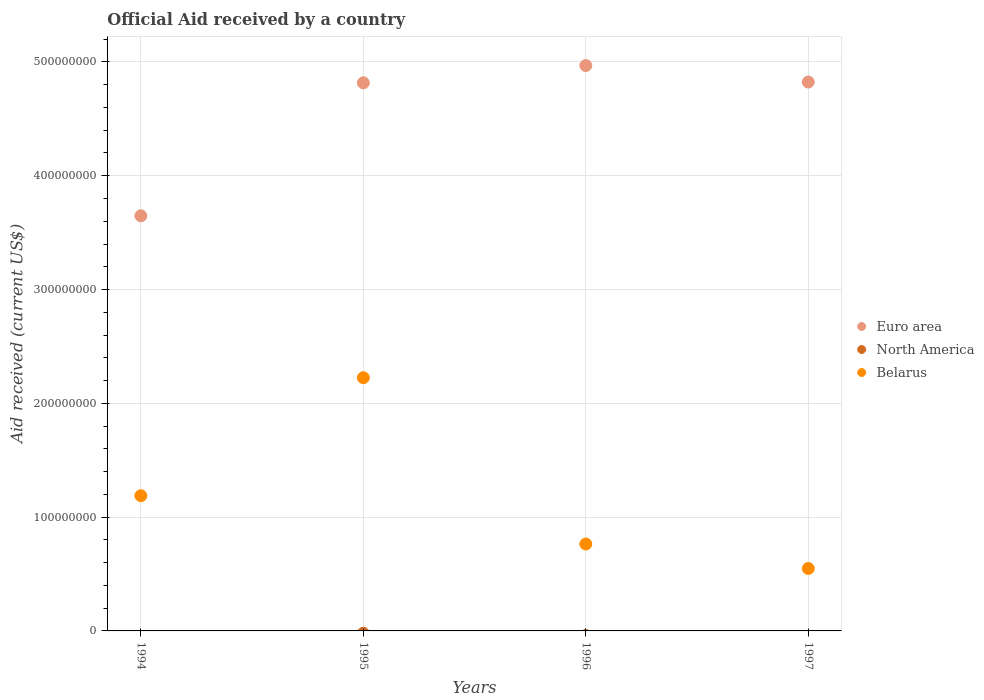How many different coloured dotlines are there?
Offer a terse response. 2. Is the number of dotlines equal to the number of legend labels?
Give a very brief answer. No. What is the net official aid received in Euro area in 1997?
Your answer should be very brief. 4.82e+08. Across all years, what is the maximum net official aid received in Belarus?
Give a very brief answer. 2.23e+08. Across all years, what is the minimum net official aid received in North America?
Provide a succinct answer. 0. What is the total net official aid received in North America in the graph?
Your answer should be compact. 0. What is the difference between the net official aid received in Euro area in 1994 and that in 1997?
Ensure brevity in your answer.  -1.18e+08. What is the difference between the net official aid received in Euro area in 1994 and the net official aid received in Belarus in 1995?
Keep it short and to the point. 1.42e+08. What is the average net official aid received in North America per year?
Keep it short and to the point. 0. In the year 1996, what is the difference between the net official aid received in Euro area and net official aid received in Belarus?
Provide a succinct answer. 4.20e+08. What is the ratio of the net official aid received in Euro area in 1996 to that in 1997?
Ensure brevity in your answer.  1.03. What is the difference between the highest and the second highest net official aid received in Euro area?
Provide a succinct answer. 1.45e+07. What is the difference between the highest and the lowest net official aid received in Belarus?
Ensure brevity in your answer.  1.68e+08. In how many years, is the net official aid received in North America greater than the average net official aid received in North America taken over all years?
Make the answer very short. 0. Is the net official aid received in North America strictly less than the net official aid received in Euro area over the years?
Provide a succinct answer. Yes. How many dotlines are there?
Provide a succinct answer. 2. How many years are there in the graph?
Ensure brevity in your answer.  4. Where does the legend appear in the graph?
Your answer should be very brief. Center right. What is the title of the graph?
Your response must be concise. Official Aid received by a country. What is the label or title of the X-axis?
Offer a terse response. Years. What is the label or title of the Y-axis?
Provide a short and direct response. Aid received (current US$). What is the Aid received (current US$) of Euro area in 1994?
Make the answer very short. 3.65e+08. What is the Aid received (current US$) of Belarus in 1994?
Keep it short and to the point. 1.19e+08. What is the Aid received (current US$) in Euro area in 1995?
Ensure brevity in your answer.  4.82e+08. What is the Aid received (current US$) in North America in 1995?
Your answer should be very brief. 0. What is the Aid received (current US$) of Belarus in 1995?
Your answer should be compact. 2.23e+08. What is the Aid received (current US$) in Euro area in 1996?
Make the answer very short. 4.97e+08. What is the Aid received (current US$) of Belarus in 1996?
Provide a short and direct response. 7.64e+07. What is the Aid received (current US$) in Euro area in 1997?
Keep it short and to the point. 4.82e+08. What is the Aid received (current US$) of Belarus in 1997?
Ensure brevity in your answer.  5.49e+07. Across all years, what is the maximum Aid received (current US$) in Euro area?
Provide a succinct answer. 4.97e+08. Across all years, what is the maximum Aid received (current US$) of Belarus?
Keep it short and to the point. 2.23e+08. Across all years, what is the minimum Aid received (current US$) of Euro area?
Keep it short and to the point. 3.65e+08. Across all years, what is the minimum Aid received (current US$) in Belarus?
Give a very brief answer. 5.49e+07. What is the total Aid received (current US$) of Euro area in the graph?
Your response must be concise. 1.83e+09. What is the total Aid received (current US$) of Belarus in the graph?
Provide a short and direct response. 4.73e+08. What is the difference between the Aid received (current US$) of Euro area in 1994 and that in 1995?
Provide a succinct answer. -1.17e+08. What is the difference between the Aid received (current US$) of Belarus in 1994 and that in 1995?
Offer a very short reply. -1.04e+08. What is the difference between the Aid received (current US$) in Euro area in 1994 and that in 1996?
Offer a terse response. -1.32e+08. What is the difference between the Aid received (current US$) of Belarus in 1994 and that in 1996?
Offer a very short reply. 4.24e+07. What is the difference between the Aid received (current US$) of Euro area in 1994 and that in 1997?
Ensure brevity in your answer.  -1.18e+08. What is the difference between the Aid received (current US$) of Belarus in 1994 and that in 1997?
Your answer should be compact. 6.39e+07. What is the difference between the Aid received (current US$) of Euro area in 1995 and that in 1996?
Your response must be concise. -1.52e+07. What is the difference between the Aid received (current US$) of Belarus in 1995 and that in 1996?
Ensure brevity in your answer.  1.46e+08. What is the difference between the Aid received (current US$) of Euro area in 1995 and that in 1997?
Your response must be concise. -6.70e+05. What is the difference between the Aid received (current US$) in Belarus in 1995 and that in 1997?
Give a very brief answer. 1.68e+08. What is the difference between the Aid received (current US$) of Euro area in 1996 and that in 1997?
Your response must be concise. 1.45e+07. What is the difference between the Aid received (current US$) of Belarus in 1996 and that in 1997?
Ensure brevity in your answer.  2.15e+07. What is the difference between the Aid received (current US$) in Euro area in 1994 and the Aid received (current US$) in Belarus in 1995?
Your response must be concise. 1.42e+08. What is the difference between the Aid received (current US$) of Euro area in 1994 and the Aid received (current US$) of Belarus in 1996?
Your answer should be compact. 2.88e+08. What is the difference between the Aid received (current US$) in Euro area in 1994 and the Aid received (current US$) in Belarus in 1997?
Your answer should be compact. 3.10e+08. What is the difference between the Aid received (current US$) of Euro area in 1995 and the Aid received (current US$) of Belarus in 1996?
Ensure brevity in your answer.  4.05e+08. What is the difference between the Aid received (current US$) of Euro area in 1995 and the Aid received (current US$) of Belarus in 1997?
Offer a terse response. 4.27e+08. What is the difference between the Aid received (current US$) of Euro area in 1996 and the Aid received (current US$) of Belarus in 1997?
Your answer should be very brief. 4.42e+08. What is the average Aid received (current US$) of Euro area per year?
Your response must be concise. 4.56e+08. What is the average Aid received (current US$) in Belarus per year?
Provide a succinct answer. 1.18e+08. In the year 1994, what is the difference between the Aid received (current US$) in Euro area and Aid received (current US$) in Belarus?
Provide a succinct answer. 2.46e+08. In the year 1995, what is the difference between the Aid received (current US$) of Euro area and Aid received (current US$) of Belarus?
Provide a short and direct response. 2.59e+08. In the year 1996, what is the difference between the Aid received (current US$) in Euro area and Aid received (current US$) in Belarus?
Provide a succinct answer. 4.20e+08. In the year 1997, what is the difference between the Aid received (current US$) in Euro area and Aid received (current US$) in Belarus?
Keep it short and to the point. 4.27e+08. What is the ratio of the Aid received (current US$) in Euro area in 1994 to that in 1995?
Your answer should be very brief. 0.76. What is the ratio of the Aid received (current US$) of Belarus in 1994 to that in 1995?
Offer a very short reply. 0.53. What is the ratio of the Aid received (current US$) of Euro area in 1994 to that in 1996?
Offer a very short reply. 0.73. What is the ratio of the Aid received (current US$) of Belarus in 1994 to that in 1996?
Provide a short and direct response. 1.56. What is the ratio of the Aid received (current US$) of Euro area in 1994 to that in 1997?
Your answer should be very brief. 0.76. What is the ratio of the Aid received (current US$) of Belarus in 1994 to that in 1997?
Your answer should be compact. 2.17. What is the ratio of the Aid received (current US$) of Euro area in 1995 to that in 1996?
Ensure brevity in your answer.  0.97. What is the ratio of the Aid received (current US$) in Belarus in 1995 to that in 1996?
Offer a terse response. 2.91. What is the ratio of the Aid received (current US$) in Euro area in 1995 to that in 1997?
Provide a short and direct response. 1. What is the ratio of the Aid received (current US$) of Belarus in 1995 to that in 1997?
Give a very brief answer. 4.05. What is the ratio of the Aid received (current US$) of Euro area in 1996 to that in 1997?
Offer a very short reply. 1.03. What is the ratio of the Aid received (current US$) in Belarus in 1996 to that in 1997?
Your answer should be very brief. 1.39. What is the difference between the highest and the second highest Aid received (current US$) of Euro area?
Your response must be concise. 1.45e+07. What is the difference between the highest and the second highest Aid received (current US$) of Belarus?
Keep it short and to the point. 1.04e+08. What is the difference between the highest and the lowest Aid received (current US$) of Euro area?
Offer a terse response. 1.32e+08. What is the difference between the highest and the lowest Aid received (current US$) of Belarus?
Give a very brief answer. 1.68e+08. 